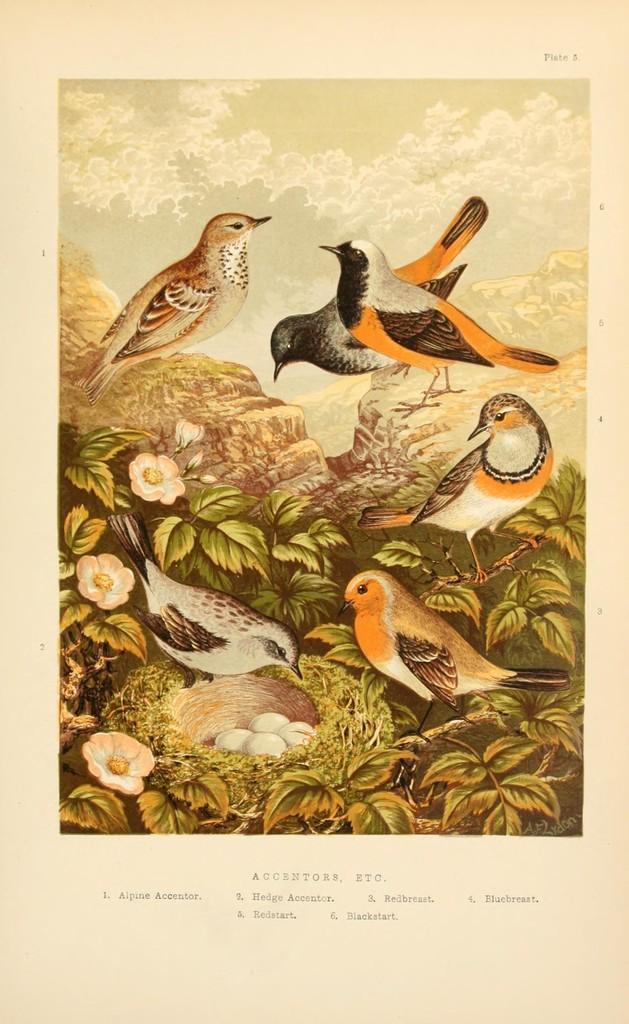Can you describe this image briefly? In this image I can see few birds in multi color, I can also see few flowers in white color, eggs also in white color and the leaves are in green color. 